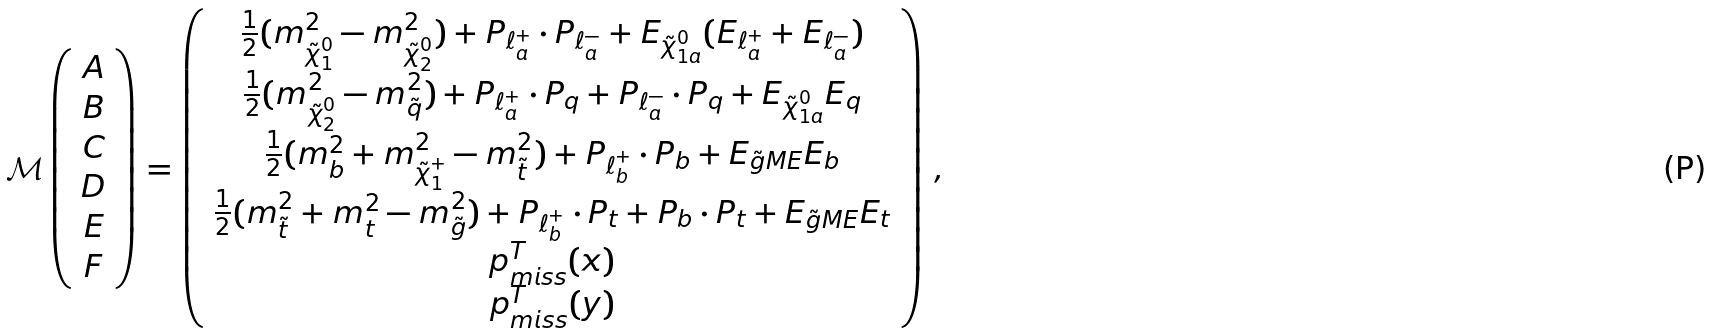Convert formula to latex. <formula><loc_0><loc_0><loc_500><loc_500>\mathcal { M } \left ( \begin{array} { c } A \\ B \\ C \\ D \\ E \\ F \end{array} \right ) = \left ( \begin{array} { c } \frac { 1 } { 2 } ( m ^ { 2 } _ { \tilde { \chi } ^ { 0 } _ { 1 } } - m ^ { 2 } _ { \tilde { \chi } ^ { 0 } _ { 2 } } ) + P _ { \ell ^ { + } _ { a } } \cdot P _ { \ell ^ { - } _ { a } } + E _ { \tilde { \chi } ^ { 0 } _ { 1 a } } ( E _ { \ell ^ { + } _ { a } } + E _ { \ell ^ { - } _ { a } } ) \\ \frac { 1 } { 2 } ( m ^ { 2 } _ { \tilde { \chi } ^ { 0 } _ { 2 } } - m ^ { 2 } _ { \tilde { q } } ) + P _ { \ell ^ { + } _ { a } } \cdot P _ { q } + P _ { \ell ^ { - } _ { a } } \cdot P _ { q } + E _ { \tilde { \chi } ^ { 0 } _ { 1 a } } E _ { q } \\ \frac { 1 } { 2 } ( m ^ { 2 } _ { b } + m ^ { 2 } _ { \tilde { \chi } ^ { + } _ { 1 } } - m ^ { 2 } _ { \tilde { t } } ) + P _ { \ell ^ { + } _ { b } } \cdot P _ { b } + E _ { \tilde { g } M E } E _ { b } \\ \frac { 1 } { 2 } ( m ^ { 2 } _ { \tilde { t } } + m ^ { 2 } _ { t } - m ^ { 2 } _ { \tilde { g } } ) + P _ { \ell ^ { + } _ { b } } \cdot P _ { t } + P _ { b } \cdot P _ { t } + E _ { \tilde { g } M E } E _ { t } \\ p ^ { T } _ { m i s s } ( x ) \\ p ^ { T } _ { m i s s } ( y ) \\ \end{array} \right ) \, ,</formula> 